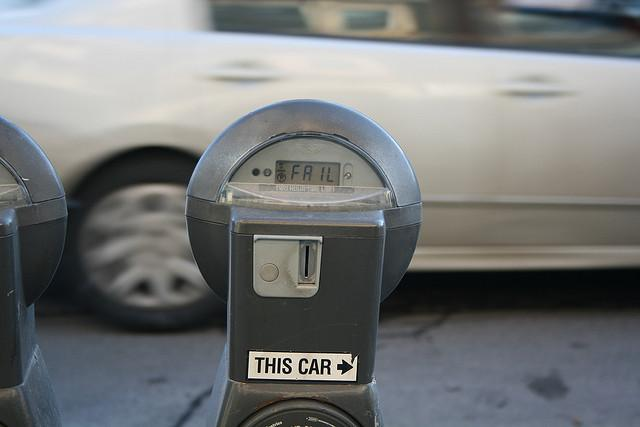Which direction is this meter pointing towards? Please explain your reasoning. right. A meter has an arrow on it that points to the right. 